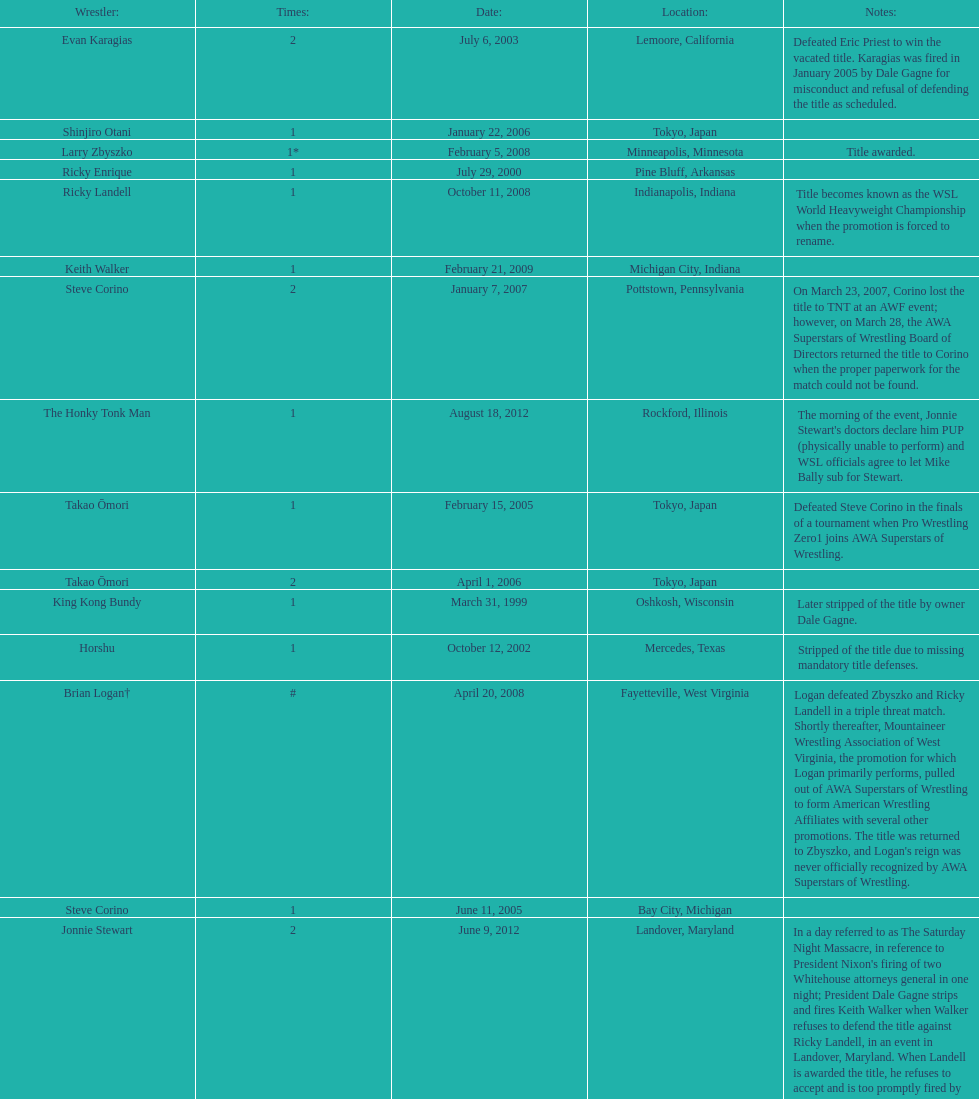How many times has ricky landell held the wsl title? 1. Help me parse the entirety of this table. {'header': ['Wrestler:', 'Times:', 'Date:', 'Location:', 'Notes:'], 'rows': [['Evan Karagias', '2', 'July 6, 2003', 'Lemoore, California', 'Defeated Eric Priest to win the vacated title. Karagias was fired in January 2005 by Dale Gagne for misconduct and refusal of defending the title as scheduled.'], ['Shinjiro Otani', '1', 'January 22, 2006', 'Tokyo, Japan', ''], ['Larry Zbyszko', '1*', 'February 5, 2008', 'Minneapolis, Minnesota', 'Title awarded.'], ['Ricky Enrique', '1', 'July 29, 2000', 'Pine Bluff, Arkansas', ''], ['Ricky Landell', '1', 'October 11, 2008', 'Indianapolis, Indiana', 'Title becomes known as the WSL World Heavyweight Championship when the promotion is forced to rename.'], ['Keith Walker', '1', 'February 21, 2009', 'Michigan City, Indiana', ''], ['Steve Corino', '2', 'January 7, 2007', 'Pottstown, Pennsylvania', 'On March 23, 2007, Corino lost the title to TNT at an AWF event; however, on March 28, the AWA Superstars of Wrestling Board of Directors returned the title to Corino when the proper paperwork for the match could not be found.'], ['The Honky Tonk Man', '1', 'August 18, 2012', 'Rockford, Illinois', "The morning of the event, Jonnie Stewart's doctors declare him PUP (physically unable to perform) and WSL officials agree to let Mike Bally sub for Stewart."], ['Takao Ōmori', '1', 'February 15, 2005', 'Tokyo, Japan', 'Defeated Steve Corino in the finals of a tournament when Pro Wrestling Zero1 joins AWA Superstars of Wrestling.'], ['Takao Ōmori', '2', 'April 1, 2006', 'Tokyo, Japan', ''], ['King Kong Bundy', '1', 'March 31, 1999', 'Oshkosh, Wisconsin', 'Later stripped of the title by owner Dale Gagne.'], ['Horshu', '1', 'October 12, 2002', 'Mercedes, Texas', 'Stripped of the title due to missing mandatory title defenses.'], ['Brian Logan†', '#', 'April 20, 2008', 'Fayetteville, West Virginia', "Logan defeated Zbyszko and Ricky Landell in a triple threat match. Shortly thereafter, Mountaineer Wrestling Association of West Virginia, the promotion for which Logan primarily performs, pulled out of AWA Superstars of Wrestling to form American Wrestling Affiliates with several other promotions. The title was returned to Zbyszko, and Logan's reign was never officially recognized by AWA Superstars of Wrestling."], ['Steve Corino', '1', 'June 11, 2005', 'Bay City, Michigan', ''], ['Jonnie Stewart', '2', 'June 9, 2012', 'Landover, Maryland', "In a day referred to as The Saturday Night Massacre, in reference to President Nixon's firing of two Whitehouse attorneys general in one night; President Dale Gagne strips and fires Keith Walker when Walker refuses to defend the title against Ricky Landell, in an event in Landover, Maryland. When Landell is awarded the title, he refuses to accept and is too promptly fired by Gagne, who than awards the title to Jonnie Stewart."], ['Larry Zbyszko', '1*', '', '', 'Title returned to Zbyszko.'], ['The Patriot\\n(Danny Dominion)', '1', 'July 29, 2000', 'Pine Bluff, Arkansas', 'Defeated Dale Gagne in an impromptu match to win the title.'], ['Jonnie Stewart', '1', 'June 6, 1996', 'Rochester, Minnesota', 'Defeated Larry Gligorovich to win the AWA Superstars of Wrestling World Heavyweight Championship.'], ['Masato Tanaka', '1', 'October 26, 2007', 'Tokyo, Japan', ''], ['Ric Converse', '1', 'June 14, 2006', 'Indianapolis, Indiana', ''], ['Takao Ōmori', '3', 'March 31, 2007', 'Yokohama, Japan', ''], ['Evan Karagias', '1', 'March 22, 2002', 'Casa Grande, Arizona', ''], ['Eric Priest', '1', 'June 3, 2001', 'Hillside, Illinois', '']]} 